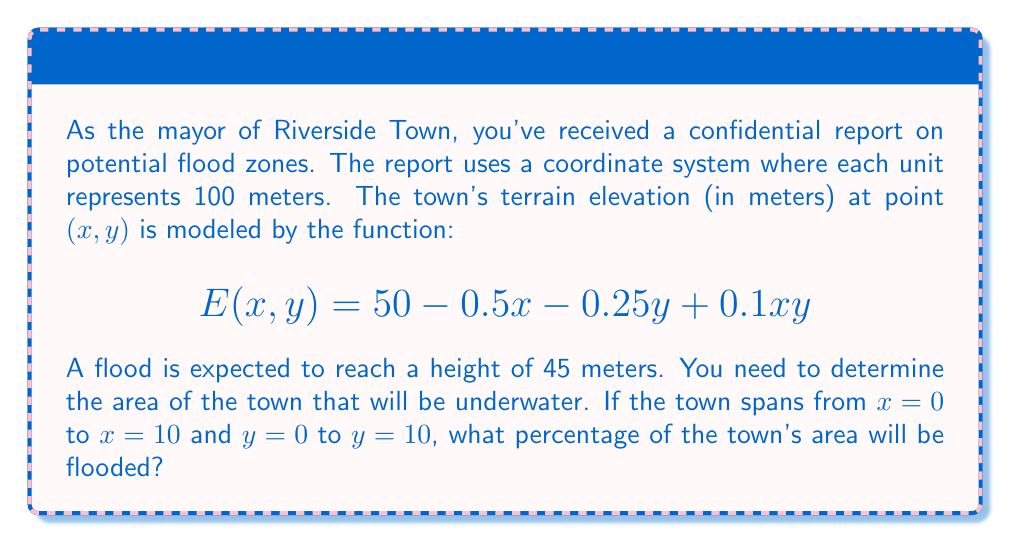Give your solution to this math problem. To solve this problem, we need to follow these steps:

1) First, we need to find the points where the elevation is equal to the flood height. This forms the boundary of the flooded area. We set up the equation:

   $$45 = 50 - 0.5x - 0.25y + 0.1xy$$

2) Rearranging the equation:

   $$0.1xy - 0.5x - 0.25y - 5 = 0$$

3) This is the equation of a hyperbola. To find the area under this curve within our town limits, we need to use numerical integration methods, which is beyond the scope of this problem.

4) Instead, we can approximate the solution by checking a grid of points. Let's check the elevation at each integer coordinate:

   For each point $(i,j)$ where $i$ and $j$ are integers from 0 to 10:
   If $50 - 0.5i - 0.25j + 0.1ij < 45$, the point is flooded.

5) Counting the flooded points:
   (0,0), (1,0), (2,0), (3,0), (4,0), (5,0)
   (0,1), (1,1), (2,1), (3,1), (4,1)
   (0,2), (1,2), (2,2), (3,2)
   (0,3), (1,3), (2,3)
   (0,4), (1,4)
   (0,5), (1,5)
   (0,6)
   (0,7)
   (0,8)
   (0,9)
   (0,10)

   Total flooded points: 26

6) Each point represents a 100m x 100m area (1 hectare). The total town area is 100 hectares.

7) The percentage of flooded area is thus approximately:

   $$\frac{26}{100} \times 100\% = 26\%$$

This is an approximation, as we're using discrete points to estimate a continuous area.
Answer: Approximately 26% of the town's area will be flooded. 